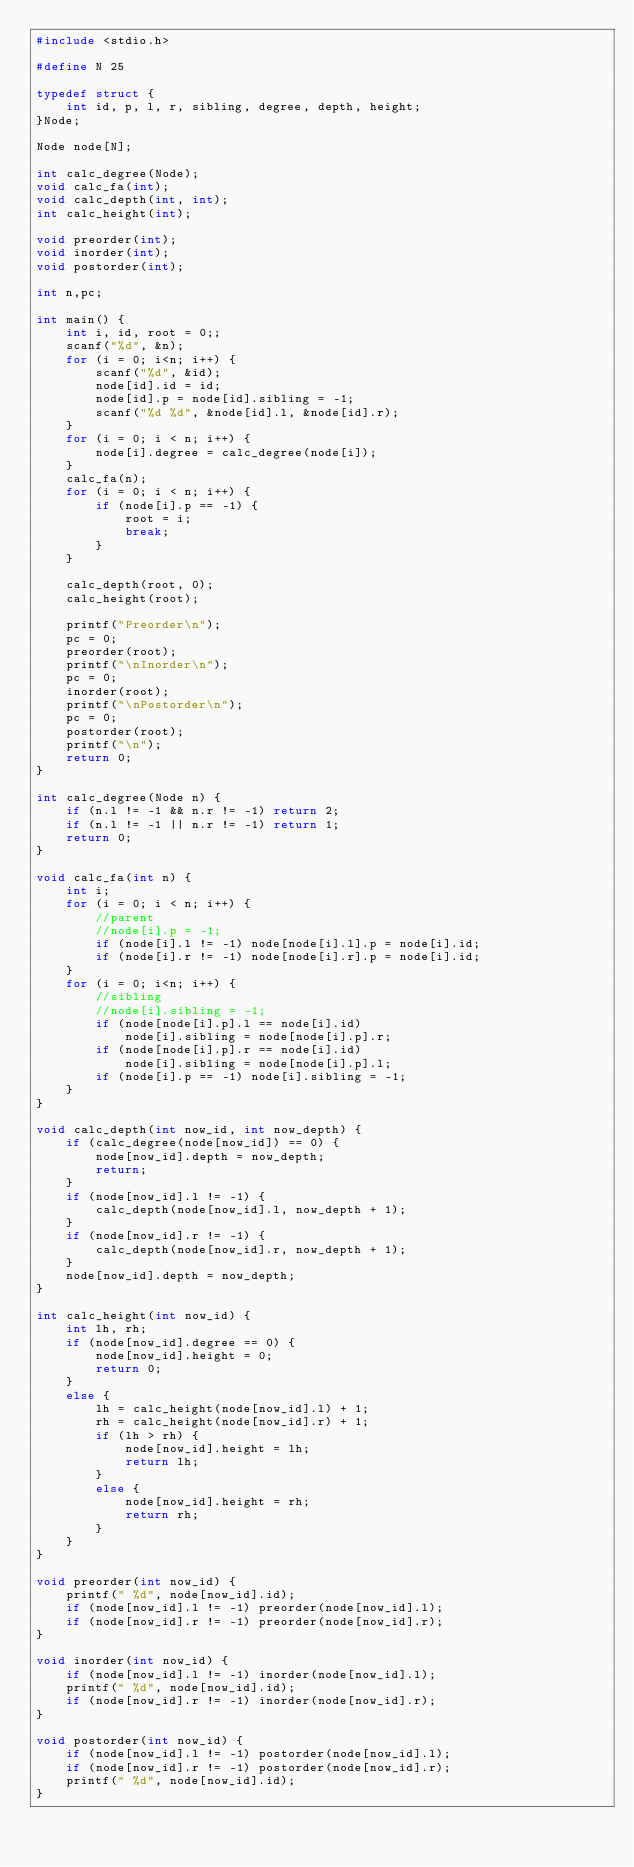<code> <loc_0><loc_0><loc_500><loc_500><_C_>#include <stdio.h>

#define N 25

typedef struct {
	int id, p, l, r, sibling, degree, depth, height;
}Node;

Node node[N];

int calc_degree(Node);
void calc_fa(int);
void calc_depth(int, int);
int calc_height(int);

void preorder(int);
void inorder(int);
void postorder(int);

int n,pc;

int main() {
	int i, id, root = 0;;
	scanf("%d", &n);
	for (i = 0; i<n; i++) {
		scanf("%d", &id);
		node[id].id = id;
		node[id].p = node[id].sibling = -1;
		scanf("%d %d", &node[id].l, &node[id].r);
	}
	for (i = 0; i < n; i++) {
		node[i].degree = calc_degree(node[i]);
	}
	calc_fa(n);
	for (i = 0; i < n; i++) {
		if (node[i].p == -1) {
			root = i;
			break;
		}
	}

	calc_depth(root, 0);
	calc_height(root);

	printf("Preorder\n");
	pc = 0;
	preorder(root);
	printf("\nInorder\n");
	pc = 0;
	inorder(root);
	printf("\nPostorder\n");
	pc = 0;
	postorder(root);
	printf("\n");
	return 0;
}

int calc_degree(Node n) {
	if (n.l != -1 && n.r != -1) return 2;
	if (n.l != -1 || n.r != -1) return 1;
	return 0;
}

void calc_fa(int n) {
	int i;
	for (i = 0; i < n; i++) {
		//parent
		//node[i].p = -1;
		if (node[i].l != -1) node[node[i].l].p = node[i].id;
		if (node[i].r != -1) node[node[i].r].p = node[i].id;
	}
	for (i = 0; i<n; i++) {
		//sibling
		//node[i].sibling = -1;
		if (node[node[i].p].l == node[i].id)
			node[i].sibling = node[node[i].p].r;
		if (node[node[i].p].r == node[i].id)
			node[i].sibling = node[node[i].p].l;
		if (node[i].p == -1) node[i].sibling = -1;
	}
}

void calc_depth(int now_id, int now_depth) {
	if (calc_degree(node[now_id]) == 0) {
		node[now_id].depth = now_depth;
		return;
	}
	if (node[now_id].l != -1) {
		calc_depth(node[now_id].l, now_depth + 1);
	}
	if (node[now_id].r != -1) {
		calc_depth(node[now_id].r, now_depth + 1);
	}
	node[now_id].depth = now_depth;
}

int calc_height(int now_id) {
	int lh, rh;
	if (node[now_id].degree == 0) {
		node[now_id].height = 0;
		return 0;
	}
	else {
		lh = calc_height(node[now_id].l) + 1;
		rh = calc_height(node[now_id].r) + 1;
		if (lh > rh) {
			node[now_id].height = lh;
			return lh;
		}
		else {
			node[now_id].height = rh;
			return rh;
		}
	}
}

void preorder(int now_id) {
	printf(" %d", node[now_id].id);
	if (node[now_id].l != -1) preorder(node[now_id].l);
	if (node[now_id].r != -1) preorder(node[now_id].r);
}

void inorder(int now_id) {
	if (node[now_id].l != -1) inorder(node[now_id].l);
	printf(" %d", node[now_id].id);
	if (node[now_id].r != -1) inorder(node[now_id].r);
}

void postorder(int now_id) {
	if (node[now_id].l != -1) postorder(node[now_id].l);
	if (node[now_id].r != -1) postorder(node[now_id].r);
	printf(" %d", node[now_id].id);
}
</code> 